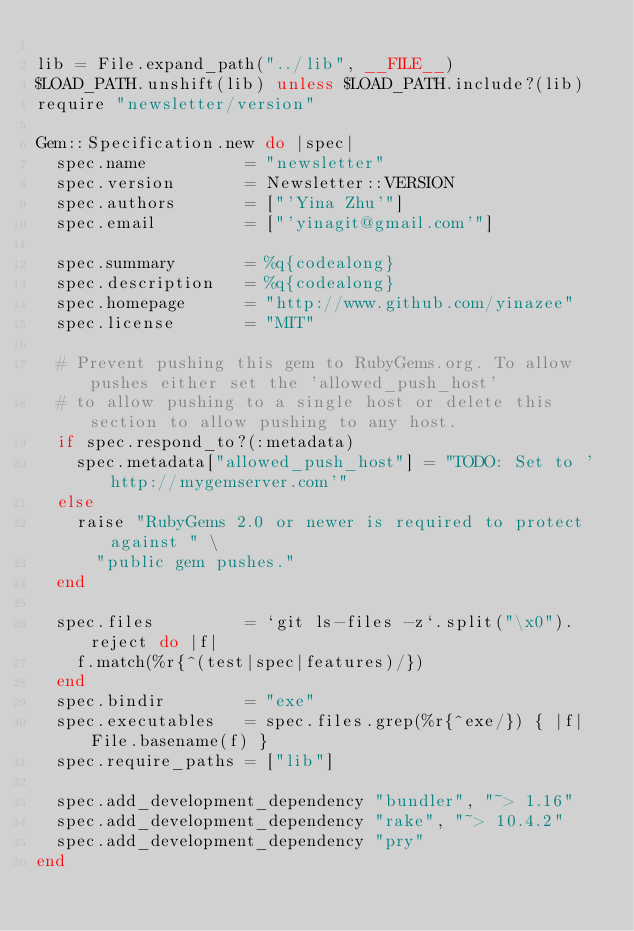<code> <loc_0><loc_0><loc_500><loc_500><_Ruby_>
lib = File.expand_path("../lib", __FILE__)
$LOAD_PATH.unshift(lib) unless $LOAD_PATH.include?(lib)
require "newsletter/version"

Gem::Specification.new do |spec|
  spec.name          = "newsletter"
  spec.version       = Newsletter::VERSION
  spec.authors       = ["'Yina Zhu'"]
  spec.email         = ["'yinagit@gmail.com'"]

  spec.summary       = %q{codealong}
  spec.description   = %q{codealong}
  spec.homepage      = "http://www.github.com/yinazee"
  spec.license       = "MIT"

  # Prevent pushing this gem to RubyGems.org. To allow pushes either set the 'allowed_push_host'
  # to allow pushing to a single host or delete this section to allow pushing to any host.
  if spec.respond_to?(:metadata)
    spec.metadata["allowed_push_host"] = "TODO: Set to 'http://mygemserver.com'"
  else
    raise "RubyGems 2.0 or newer is required to protect against " \
      "public gem pushes."
  end

  spec.files         = `git ls-files -z`.split("\x0").reject do |f|
    f.match(%r{^(test|spec|features)/})
  end
  spec.bindir        = "exe"
  spec.executables   = spec.files.grep(%r{^exe/}) { |f| File.basename(f) }
  spec.require_paths = ["lib"]

  spec.add_development_dependency "bundler", "~> 1.16"
  spec.add_development_dependency "rake", "~> 10.4.2"
  spec.add_development_dependency "pry"
end
</code> 